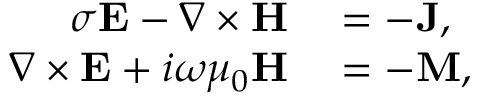Convert formula to latex. <formula><loc_0><loc_0><loc_500><loc_500>\begin{array} { r l } { \sigma E - \nabla \times H } & = - J , } \\ { \nabla \times E + i \omega \mu _ { 0 } H } & = - M , } \end{array}</formula> 